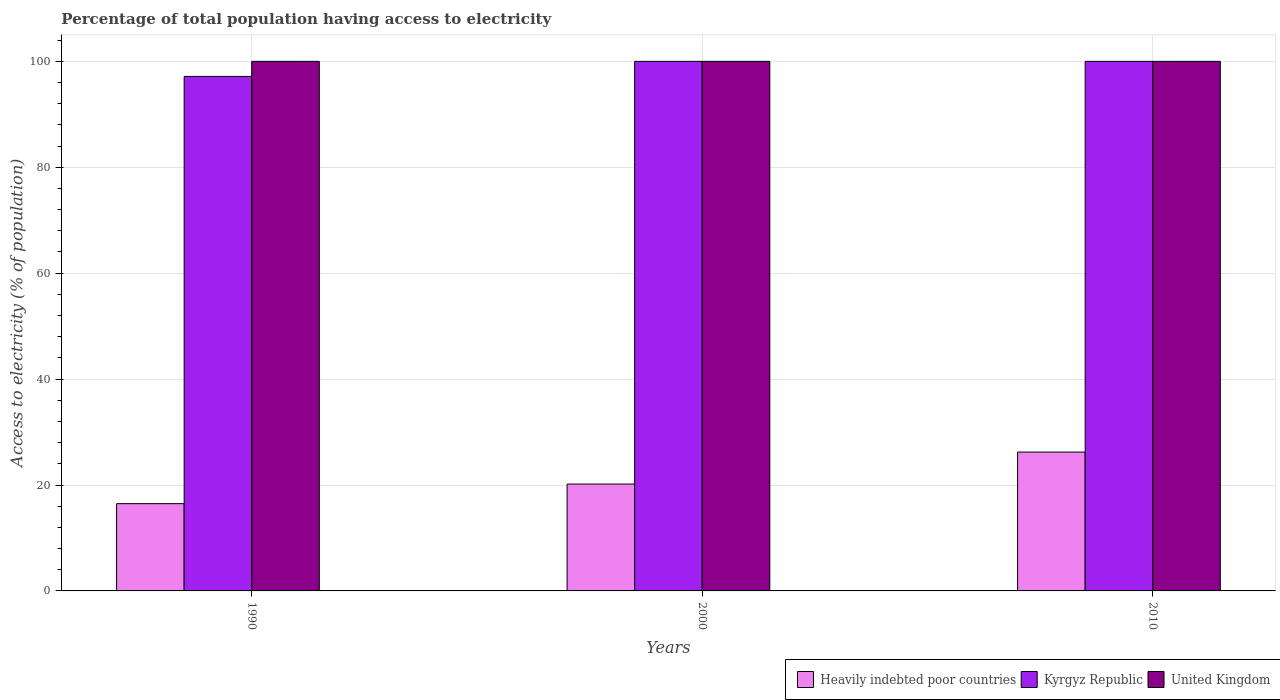Are the number of bars per tick equal to the number of legend labels?
Offer a very short reply. Yes. Are the number of bars on each tick of the X-axis equal?
Offer a terse response. Yes. What is the label of the 2nd group of bars from the left?
Make the answer very short. 2000. What is the percentage of population that have access to electricity in Heavily indebted poor countries in 2000?
Provide a succinct answer. 20.18. Across all years, what is the maximum percentage of population that have access to electricity in United Kingdom?
Provide a succinct answer. 100. Across all years, what is the minimum percentage of population that have access to electricity in Kyrgyz Republic?
Your answer should be very brief. 97.16. What is the total percentage of population that have access to electricity in Heavily indebted poor countries in the graph?
Ensure brevity in your answer.  62.89. What is the difference between the percentage of population that have access to electricity in United Kingdom in 2010 and the percentage of population that have access to electricity in Heavily indebted poor countries in 1990?
Your answer should be very brief. 83.52. What is the average percentage of population that have access to electricity in Kyrgyz Republic per year?
Offer a very short reply. 99.05. In the year 1990, what is the difference between the percentage of population that have access to electricity in Kyrgyz Republic and percentage of population that have access to electricity in United Kingdom?
Your response must be concise. -2.84. In how many years, is the percentage of population that have access to electricity in Kyrgyz Republic greater than 100 %?
Your answer should be very brief. 0. What is the ratio of the percentage of population that have access to electricity in Heavily indebted poor countries in 1990 to that in 2010?
Keep it short and to the point. 0.63. Is the percentage of population that have access to electricity in Kyrgyz Republic in 1990 less than that in 2010?
Provide a succinct answer. Yes. Is the difference between the percentage of population that have access to electricity in Kyrgyz Republic in 1990 and 2010 greater than the difference between the percentage of population that have access to electricity in United Kingdom in 1990 and 2010?
Make the answer very short. No. In how many years, is the percentage of population that have access to electricity in United Kingdom greater than the average percentage of population that have access to electricity in United Kingdom taken over all years?
Make the answer very short. 0. Is the sum of the percentage of population that have access to electricity in Kyrgyz Republic in 1990 and 2000 greater than the maximum percentage of population that have access to electricity in United Kingdom across all years?
Your answer should be compact. Yes. What does the 2nd bar from the left in 2010 represents?
Your response must be concise. Kyrgyz Republic. How many bars are there?
Your answer should be compact. 9. Are the values on the major ticks of Y-axis written in scientific E-notation?
Ensure brevity in your answer.  No. What is the title of the graph?
Your answer should be very brief. Percentage of total population having access to electricity. Does "Serbia" appear as one of the legend labels in the graph?
Give a very brief answer. No. What is the label or title of the X-axis?
Ensure brevity in your answer.  Years. What is the label or title of the Y-axis?
Your response must be concise. Access to electricity (% of population). What is the Access to electricity (% of population) of Heavily indebted poor countries in 1990?
Your answer should be very brief. 16.48. What is the Access to electricity (% of population) of Kyrgyz Republic in 1990?
Offer a very short reply. 97.16. What is the Access to electricity (% of population) in Heavily indebted poor countries in 2000?
Provide a short and direct response. 20.18. What is the Access to electricity (% of population) in United Kingdom in 2000?
Offer a very short reply. 100. What is the Access to electricity (% of population) of Heavily indebted poor countries in 2010?
Keep it short and to the point. 26.22. What is the Access to electricity (% of population) in Kyrgyz Republic in 2010?
Give a very brief answer. 100. What is the Access to electricity (% of population) in United Kingdom in 2010?
Make the answer very short. 100. Across all years, what is the maximum Access to electricity (% of population) of Heavily indebted poor countries?
Provide a succinct answer. 26.22. Across all years, what is the maximum Access to electricity (% of population) of United Kingdom?
Your answer should be compact. 100. Across all years, what is the minimum Access to electricity (% of population) of Heavily indebted poor countries?
Provide a short and direct response. 16.48. Across all years, what is the minimum Access to electricity (% of population) of Kyrgyz Republic?
Keep it short and to the point. 97.16. Across all years, what is the minimum Access to electricity (% of population) of United Kingdom?
Your answer should be very brief. 100. What is the total Access to electricity (% of population) of Heavily indebted poor countries in the graph?
Your response must be concise. 62.89. What is the total Access to electricity (% of population) in Kyrgyz Republic in the graph?
Your response must be concise. 297.16. What is the total Access to electricity (% of population) of United Kingdom in the graph?
Your response must be concise. 300. What is the difference between the Access to electricity (% of population) of Heavily indebted poor countries in 1990 and that in 2000?
Ensure brevity in your answer.  -3.7. What is the difference between the Access to electricity (% of population) of Kyrgyz Republic in 1990 and that in 2000?
Offer a terse response. -2.84. What is the difference between the Access to electricity (% of population) in Heavily indebted poor countries in 1990 and that in 2010?
Keep it short and to the point. -9.74. What is the difference between the Access to electricity (% of population) of Kyrgyz Republic in 1990 and that in 2010?
Give a very brief answer. -2.84. What is the difference between the Access to electricity (% of population) in United Kingdom in 1990 and that in 2010?
Give a very brief answer. 0. What is the difference between the Access to electricity (% of population) in Heavily indebted poor countries in 2000 and that in 2010?
Provide a short and direct response. -6.04. What is the difference between the Access to electricity (% of population) in Heavily indebted poor countries in 1990 and the Access to electricity (% of population) in Kyrgyz Republic in 2000?
Your answer should be very brief. -83.52. What is the difference between the Access to electricity (% of population) of Heavily indebted poor countries in 1990 and the Access to electricity (% of population) of United Kingdom in 2000?
Offer a terse response. -83.52. What is the difference between the Access to electricity (% of population) of Kyrgyz Republic in 1990 and the Access to electricity (% of population) of United Kingdom in 2000?
Provide a short and direct response. -2.84. What is the difference between the Access to electricity (% of population) in Heavily indebted poor countries in 1990 and the Access to electricity (% of population) in Kyrgyz Republic in 2010?
Give a very brief answer. -83.52. What is the difference between the Access to electricity (% of population) in Heavily indebted poor countries in 1990 and the Access to electricity (% of population) in United Kingdom in 2010?
Provide a succinct answer. -83.52. What is the difference between the Access to electricity (% of population) in Kyrgyz Republic in 1990 and the Access to electricity (% of population) in United Kingdom in 2010?
Keep it short and to the point. -2.84. What is the difference between the Access to electricity (% of population) in Heavily indebted poor countries in 2000 and the Access to electricity (% of population) in Kyrgyz Republic in 2010?
Make the answer very short. -79.82. What is the difference between the Access to electricity (% of population) of Heavily indebted poor countries in 2000 and the Access to electricity (% of population) of United Kingdom in 2010?
Offer a terse response. -79.82. What is the difference between the Access to electricity (% of population) in Kyrgyz Republic in 2000 and the Access to electricity (% of population) in United Kingdom in 2010?
Offer a terse response. 0. What is the average Access to electricity (% of population) in Heavily indebted poor countries per year?
Make the answer very short. 20.96. What is the average Access to electricity (% of population) of Kyrgyz Republic per year?
Your answer should be very brief. 99.05. In the year 1990, what is the difference between the Access to electricity (% of population) of Heavily indebted poor countries and Access to electricity (% of population) of Kyrgyz Republic?
Offer a terse response. -80.68. In the year 1990, what is the difference between the Access to electricity (% of population) of Heavily indebted poor countries and Access to electricity (% of population) of United Kingdom?
Give a very brief answer. -83.52. In the year 1990, what is the difference between the Access to electricity (% of population) of Kyrgyz Republic and Access to electricity (% of population) of United Kingdom?
Keep it short and to the point. -2.84. In the year 2000, what is the difference between the Access to electricity (% of population) of Heavily indebted poor countries and Access to electricity (% of population) of Kyrgyz Republic?
Make the answer very short. -79.82. In the year 2000, what is the difference between the Access to electricity (% of population) in Heavily indebted poor countries and Access to electricity (% of population) in United Kingdom?
Your answer should be compact. -79.82. In the year 2010, what is the difference between the Access to electricity (% of population) of Heavily indebted poor countries and Access to electricity (% of population) of Kyrgyz Republic?
Provide a succinct answer. -73.78. In the year 2010, what is the difference between the Access to electricity (% of population) of Heavily indebted poor countries and Access to electricity (% of population) of United Kingdom?
Provide a short and direct response. -73.78. What is the ratio of the Access to electricity (% of population) in Heavily indebted poor countries in 1990 to that in 2000?
Your response must be concise. 0.82. What is the ratio of the Access to electricity (% of population) in Kyrgyz Republic in 1990 to that in 2000?
Provide a short and direct response. 0.97. What is the ratio of the Access to electricity (% of population) in United Kingdom in 1990 to that in 2000?
Ensure brevity in your answer.  1. What is the ratio of the Access to electricity (% of population) of Heavily indebted poor countries in 1990 to that in 2010?
Offer a terse response. 0.63. What is the ratio of the Access to electricity (% of population) of Kyrgyz Republic in 1990 to that in 2010?
Your answer should be very brief. 0.97. What is the ratio of the Access to electricity (% of population) in Heavily indebted poor countries in 2000 to that in 2010?
Offer a terse response. 0.77. What is the ratio of the Access to electricity (% of population) of United Kingdom in 2000 to that in 2010?
Offer a terse response. 1. What is the difference between the highest and the second highest Access to electricity (% of population) of Heavily indebted poor countries?
Your response must be concise. 6.04. What is the difference between the highest and the second highest Access to electricity (% of population) of Kyrgyz Republic?
Ensure brevity in your answer.  0. What is the difference between the highest and the second highest Access to electricity (% of population) in United Kingdom?
Give a very brief answer. 0. What is the difference between the highest and the lowest Access to electricity (% of population) of Heavily indebted poor countries?
Provide a short and direct response. 9.74. What is the difference between the highest and the lowest Access to electricity (% of population) in Kyrgyz Republic?
Ensure brevity in your answer.  2.84. 